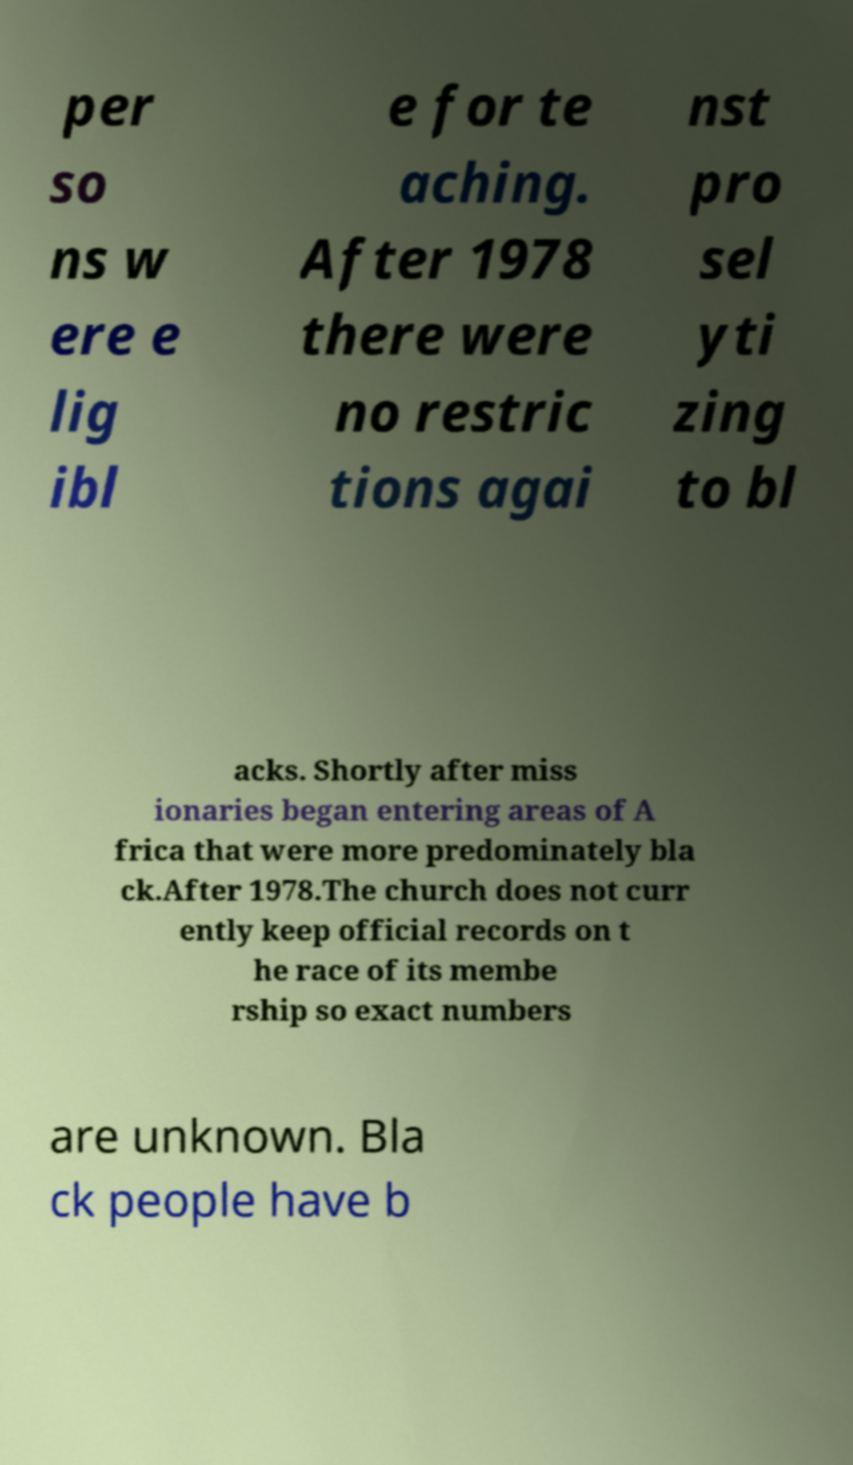Please identify and transcribe the text found in this image. per so ns w ere e lig ibl e for te aching. After 1978 there were no restric tions agai nst pro sel yti zing to bl acks. Shortly after miss ionaries began entering areas of A frica that were more predominately bla ck.After 1978.The church does not curr ently keep official records on t he race of its membe rship so exact numbers are unknown. Bla ck people have b 